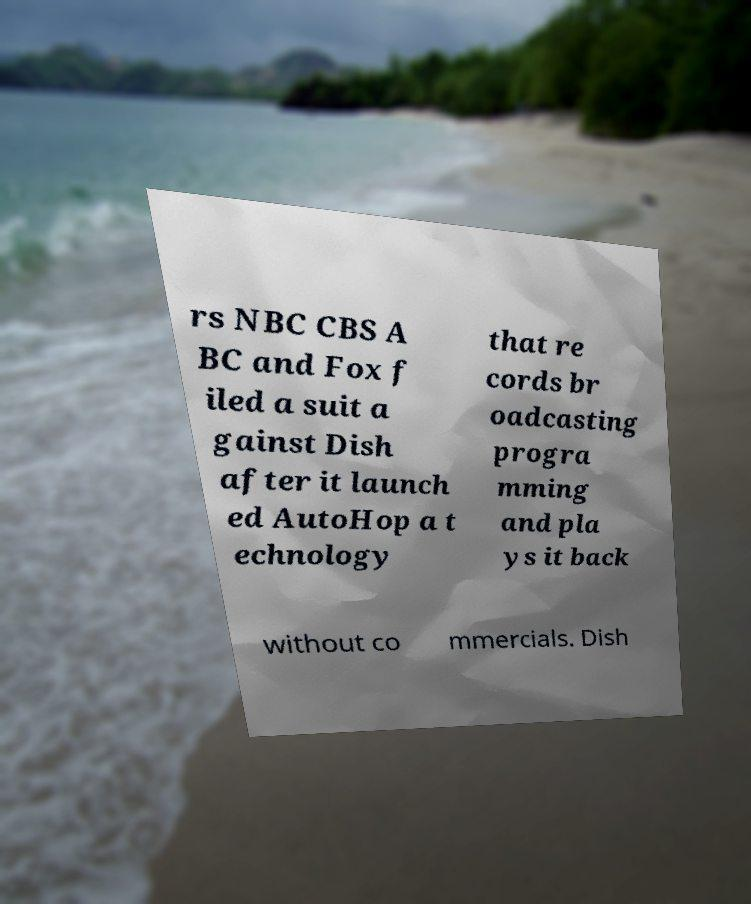Please identify and transcribe the text found in this image. rs NBC CBS A BC and Fox f iled a suit a gainst Dish after it launch ed AutoHop a t echnology that re cords br oadcasting progra mming and pla ys it back without co mmercials. Dish 